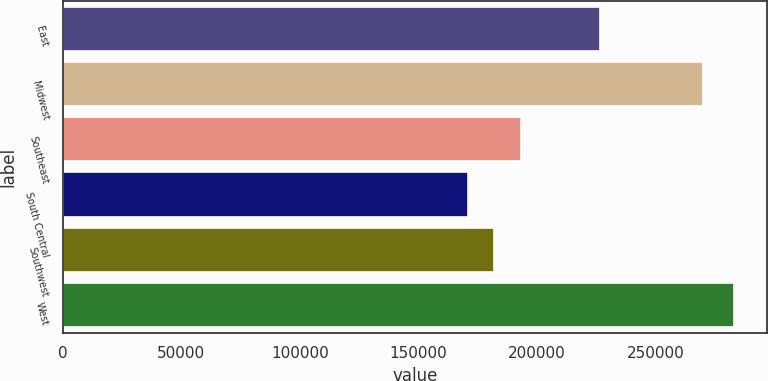Convert chart to OTSL. <chart><loc_0><loc_0><loc_500><loc_500><bar_chart><fcel>East<fcel>Midwest<fcel>Southeast<fcel>South Central<fcel>Southwest<fcel>West<nl><fcel>226500<fcel>269900<fcel>193160<fcel>170700<fcel>181930<fcel>283000<nl></chart> 